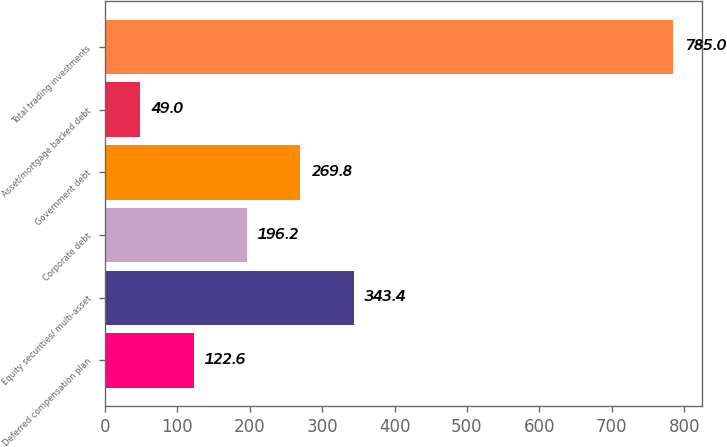<chart> <loc_0><loc_0><loc_500><loc_500><bar_chart><fcel>Deferred compensation plan<fcel>Equity securities/ multi-asset<fcel>Corporate debt<fcel>Government debt<fcel>Asset/mortgage backed debt<fcel>Total trading investments<nl><fcel>122.6<fcel>343.4<fcel>196.2<fcel>269.8<fcel>49<fcel>785<nl></chart> 